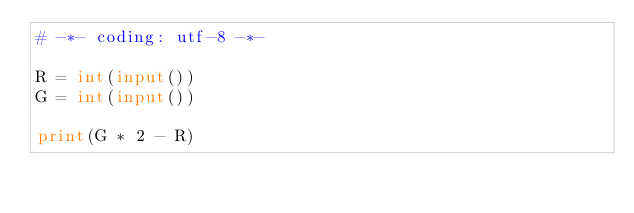<code> <loc_0><loc_0><loc_500><loc_500><_Python_># -*- coding: utf-8 -*-

R = int(input())
G = int(input())

print(G * 2 - R)
</code> 